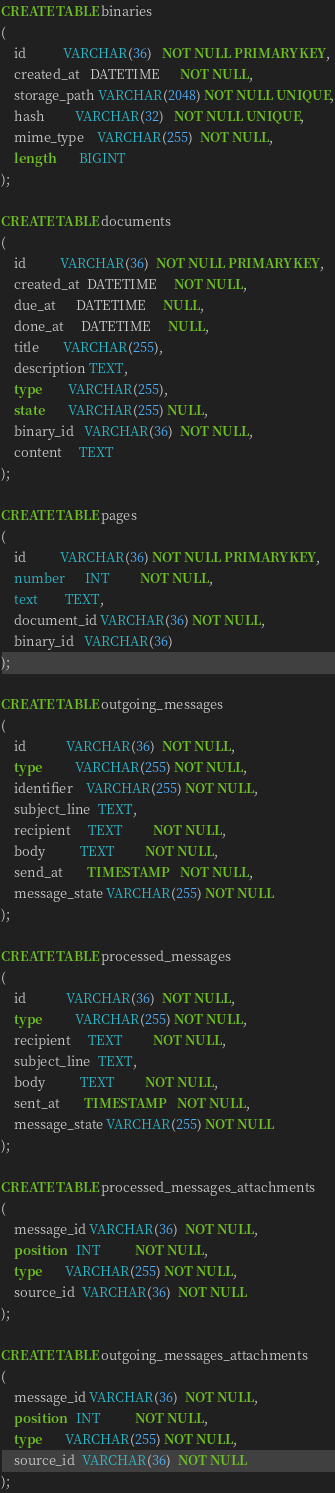Convert code to text. <code><loc_0><loc_0><loc_500><loc_500><_SQL_>CREATE TABLE binaries
(
    id           VARCHAR(36)   NOT NULL PRIMARY KEY,
    created_at   DATETIME      NOT NULL,
    storage_path VARCHAR(2048) NOT NULL UNIQUE,
    hash         VARCHAR(32)   NOT NULL UNIQUE,
    mime_type    VARCHAR(255)  NOT NULL,
    length       BIGINT
);

CREATE TABLE documents
(
    id          VARCHAR(36)  NOT NULL PRIMARY KEY,
    created_at  DATETIME     NOT NULL,
    due_at      DATETIME     NULL,
    done_at     DATETIME     NULL,
    title       VARCHAR(255),
    description TEXT,
    type        VARCHAR(255),
    state       VARCHAR(255) NULL,
    binary_id   VARCHAR(36)  NOT NULL,
    content     TEXT
);

CREATE TABLE pages
(
    id          VARCHAR(36) NOT NULL PRIMARY KEY,
    number      INT         NOT NULL,
    text        TEXT,
    document_id VARCHAR(36) NOT NULL,
    binary_id   VARCHAR(36)
);

CREATE TABLE outgoing_messages
(
    id            VARCHAR(36)  NOT NULL,
    type          VARCHAR(255) NOT NULL,
    identifier    VARCHAR(255) NOT NULL,
    subject_line  TEXT,
    recipient     TEXT         NOT NULL,
    body          TEXT         NOT NULL,
    send_at       TIMESTAMP    NOT NULL,
    message_state VARCHAR(255) NOT NULL
);

CREATE TABLE processed_messages
(
    id            VARCHAR(36)  NOT NULL,
    type          VARCHAR(255) NOT NULL,
    recipient     TEXT         NOT NULL,
    subject_line  TEXT,
    body          TEXT         NOT NULL,
    sent_at       TIMESTAMP    NOT NULL,
    message_state VARCHAR(255) NOT NULL
);

CREATE TABLE processed_messages_attachments
(
    message_id VARCHAR(36)  NOT NULL,
    position   INT          NOT NULL,
    type       VARCHAR(255) NOT NULL,
    source_id  VARCHAR(36)  NOT NULL
);

CREATE TABLE outgoing_messages_attachments
(
    message_id VARCHAR(36)  NOT NULL,
    position   INT          NOT NULL,
    type       VARCHAR(255) NOT NULL,
    source_id  VARCHAR(36)  NOT NULL
);
</code> 